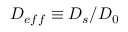<formula> <loc_0><loc_0><loc_500><loc_500>D _ { e f f } \equiv D _ { s } / D _ { 0 }</formula> 